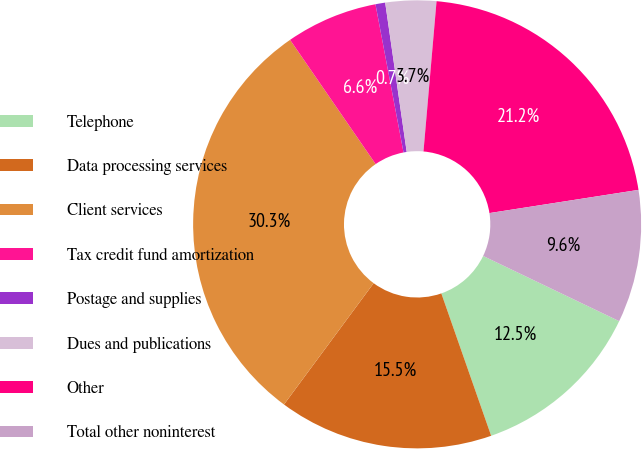Convert chart. <chart><loc_0><loc_0><loc_500><loc_500><pie_chart><fcel>Telephone<fcel>Data processing services<fcel>Client services<fcel>Tax credit fund amortization<fcel>Postage and supplies<fcel>Dues and publications<fcel>Other<fcel>Total other noninterest<nl><fcel>12.53%<fcel>15.49%<fcel>30.27%<fcel>6.62%<fcel>0.7%<fcel>3.66%<fcel>21.16%<fcel>9.57%<nl></chart> 